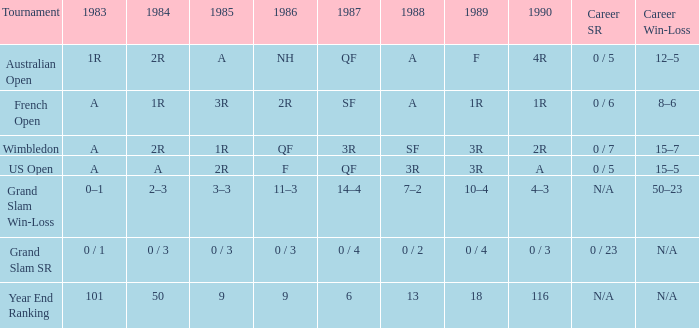In 1983 what is the tournament that is 0 / 1? Grand Slam SR. 